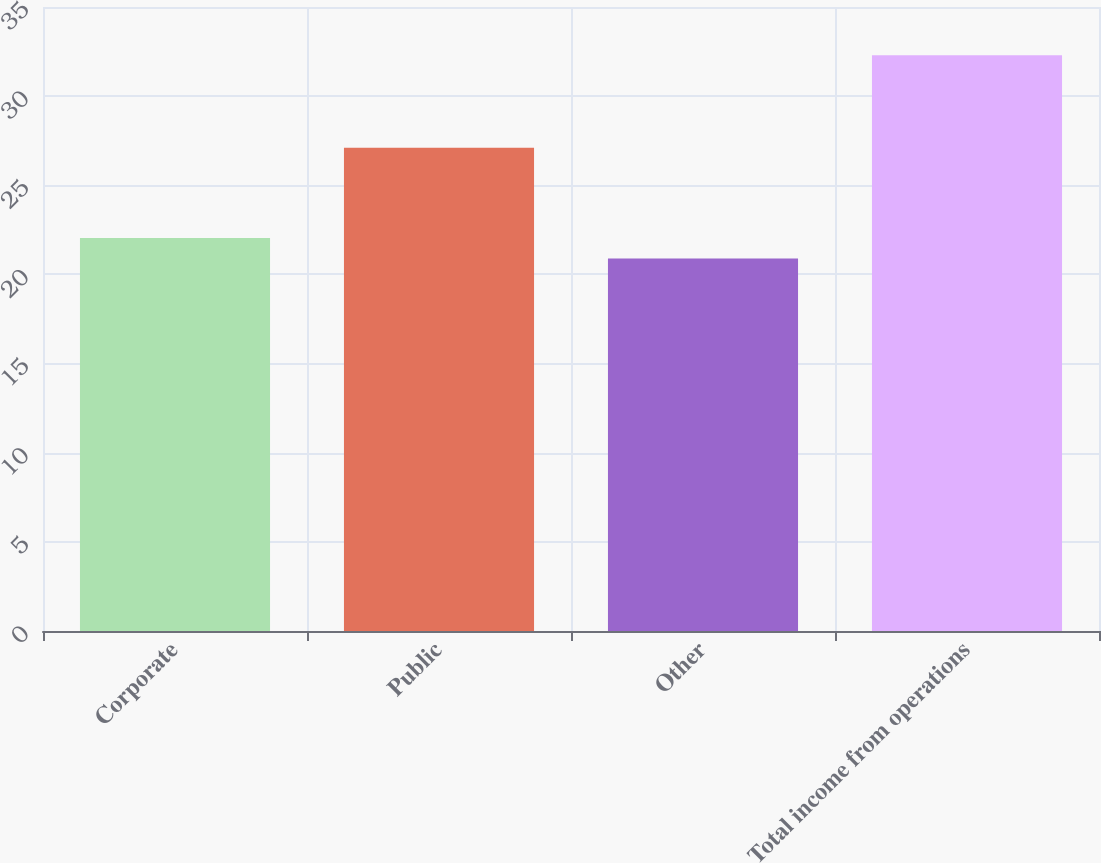<chart> <loc_0><loc_0><loc_500><loc_500><bar_chart><fcel>Corporate<fcel>Public<fcel>Other<fcel>Total income from operations<nl><fcel>22.04<fcel>27.1<fcel>20.9<fcel>32.3<nl></chart> 